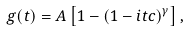<formula> <loc_0><loc_0><loc_500><loc_500>g ( t ) = A \left [ 1 - ( 1 - i t c ) ^ { \gamma } \right ] ,</formula> 